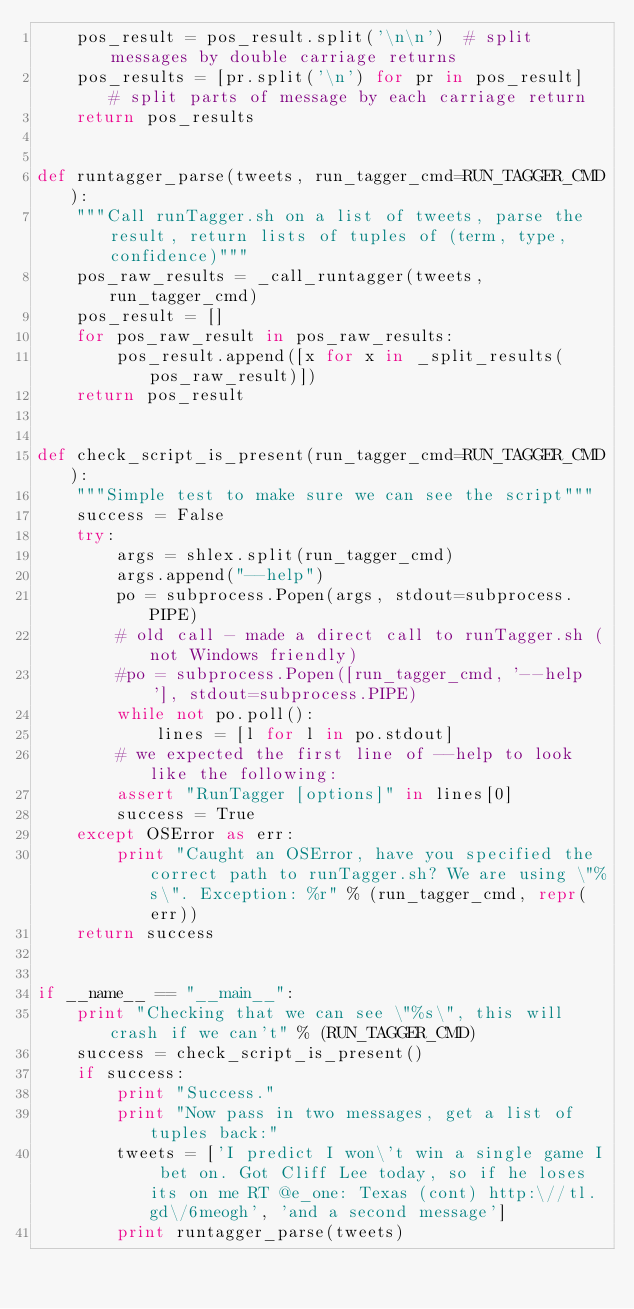<code> <loc_0><loc_0><loc_500><loc_500><_Python_>    pos_result = pos_result.split('\n\n')  # split messages by double carriage returns
    pos_results = [pr.split('\n') for pr in pos_result]  # split parts of message by each carriage return
    return pos_results


def runtagger_parse(tweets, run_tagger_cmd=RUN_TAGGER_CMD):
    """Call runTagger.sh on a list of tweets, parse the result, return lists of tuples of (term, type, confidence)"""
    pos_raw_results = _call_runtagger(tweets, run_tagger_cmd)
    pos_result = []
    for pos_raw_result in pos_raw_results:
        pos_result.append([x for x in _split_results(pos_raw_result)])
    return pos_result


def check_script_is_present(run_tagger_cmd=RUN_TAGGER_CMD):
    """Simple test to make sure we can see the script"""
    success = False
    try:
        args = shlex.split(run_tagger_cmd)
        args.append("--help")
        po = subprocess.Popen(args, stdout=subprocess.PIPE)
        # old call - made a direct call to runTagger.sh (not Windows friendly)
        #po = subprocess.Popen([run_tagger_cmd, '--help'], stdout=subprocess.PIPE)
        while not po.poll():
            lines = [l for l in po.stdout]
        # we expected the first line of --help to look like the following:
        assert "RunTagger [options]" in lines[0]
        success = True
    except OSError as err:
        print "Caught an OSError, have you specified the correct path to runTagger.sh? We are using \"%s\". Exception: %r" % (run_tagger_cmd, repr(err))
    return success


if __name__ == "__main__":
    print "Checking that we can see \"%s\", this will crash if we can't" % (RUN_TAGGER_CMD)
    success = check_script_is_present()
    if success:
        print "Success."
        print "Now pass in two messages, get a list of tuples back:"
        tweets = ['I predict I won\'t win a single game I bet on. Got Cliff Lee today, so if he loses its on me RT @e_one: Texas (cont) http:\//tl.gd\/6meogh', 'and a second message']
        print runtagger_parse(tweets)</code> 